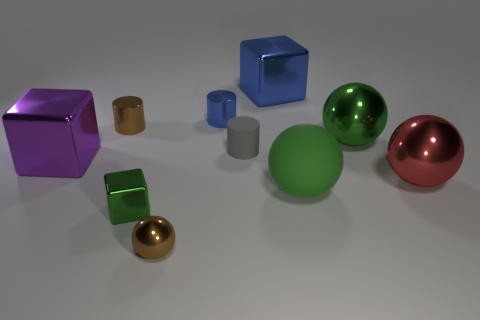Subtract all big cubes. How many cubes are left? 1 Subtract 2 cylinders. How many cylinders are left? 1 Subtract all green blocks. How many blocks are left? 2 Subtract all blocks. How many objects are left? 7 Subtract all gray cylinders. How many purple cubes are left? 1 Subtract all tiny shiny cylinders. Subtract all big purple shiny things. How many objects are left? 7 Add 3 blue shiny things. How many blue shiny things are left? 5 Add 8 red cubes. How many red cubes exist? 8 Subtract 0 purple spheres. How many objects are left? 10 Subtract all blue cylinders. Subtract all green cubes. How many cylinders are left? 2 